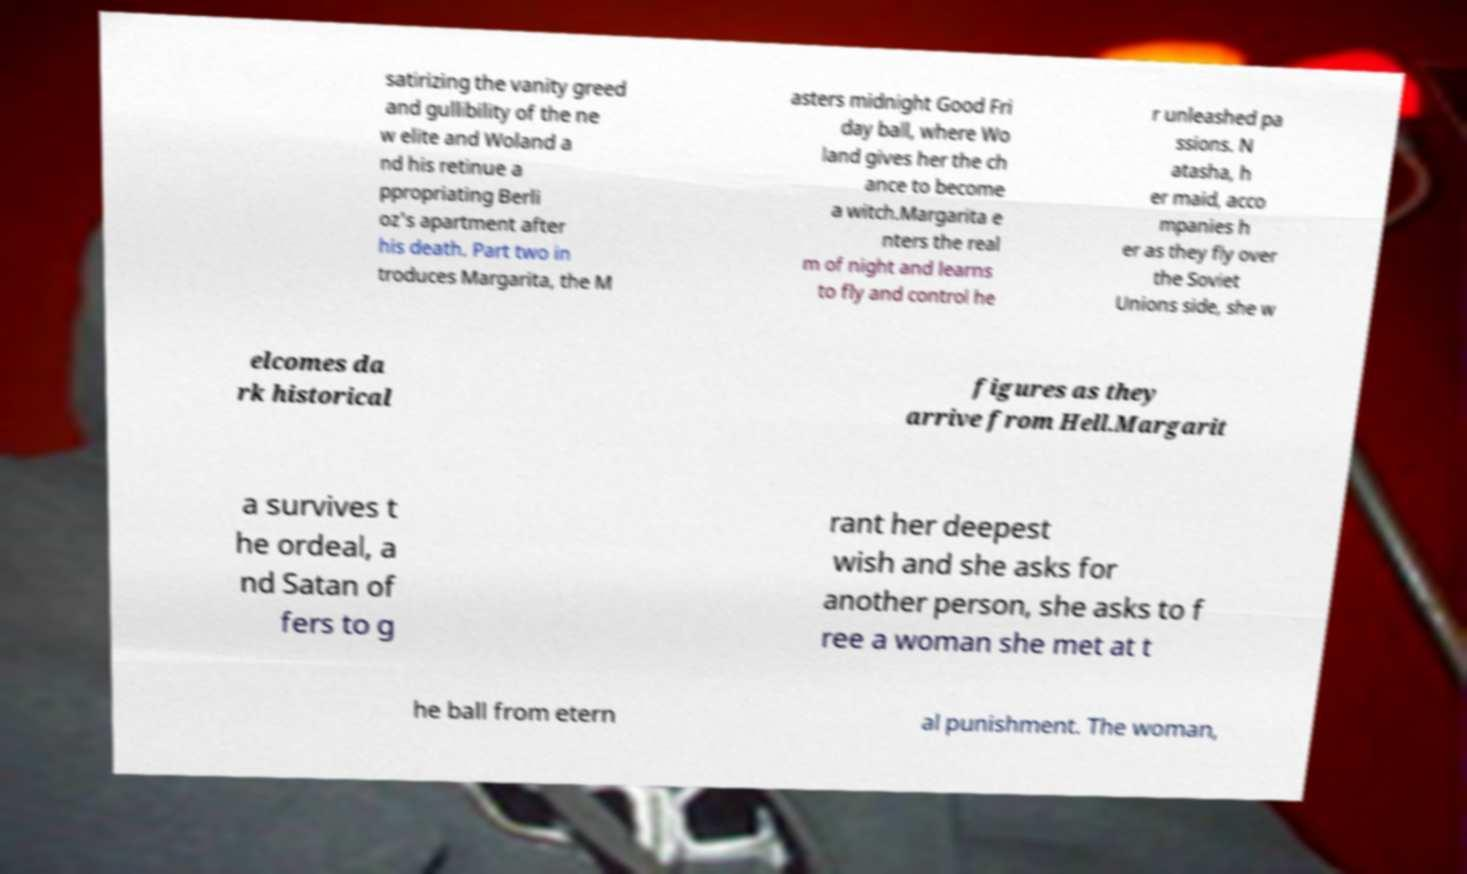For documentation purposes, I need the text within this image transcribed. Could you provide that? satirizing the vanity greed and gullibility of the ne w elite and Woland a nd his retinue a ppropriating Berli oz's apartment after his death. Part two in troduces Margarita, the M asters midnight Good Fri day ball, where Wo land gives her the ch ance to become a witch.Margarita e nters the real m of night and learns to fly and control he r unleashed pa ssions. N atasha, h er maid, acco mpanies h er as they fly over the Soviet Unions side, she w elcomes da rk historical figures as they arrive from Hell.Margarit a survives t he ordeal, a nd Satan of fers to g rant her deepest wish and she asks for another person, she asks to f ree a woman she met at t he ball from etern al punishment. The woman, 